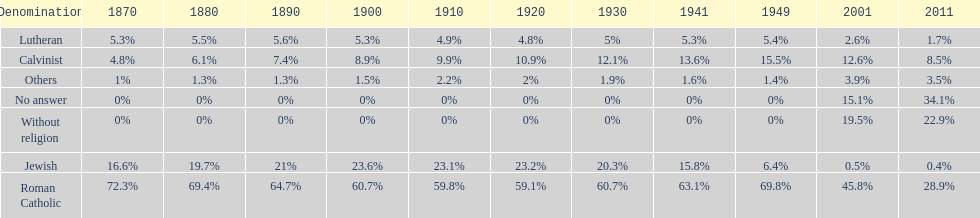Which religious denomination had a higher percentage in 1900, jewish or roman catholic? Roman Catholic. 